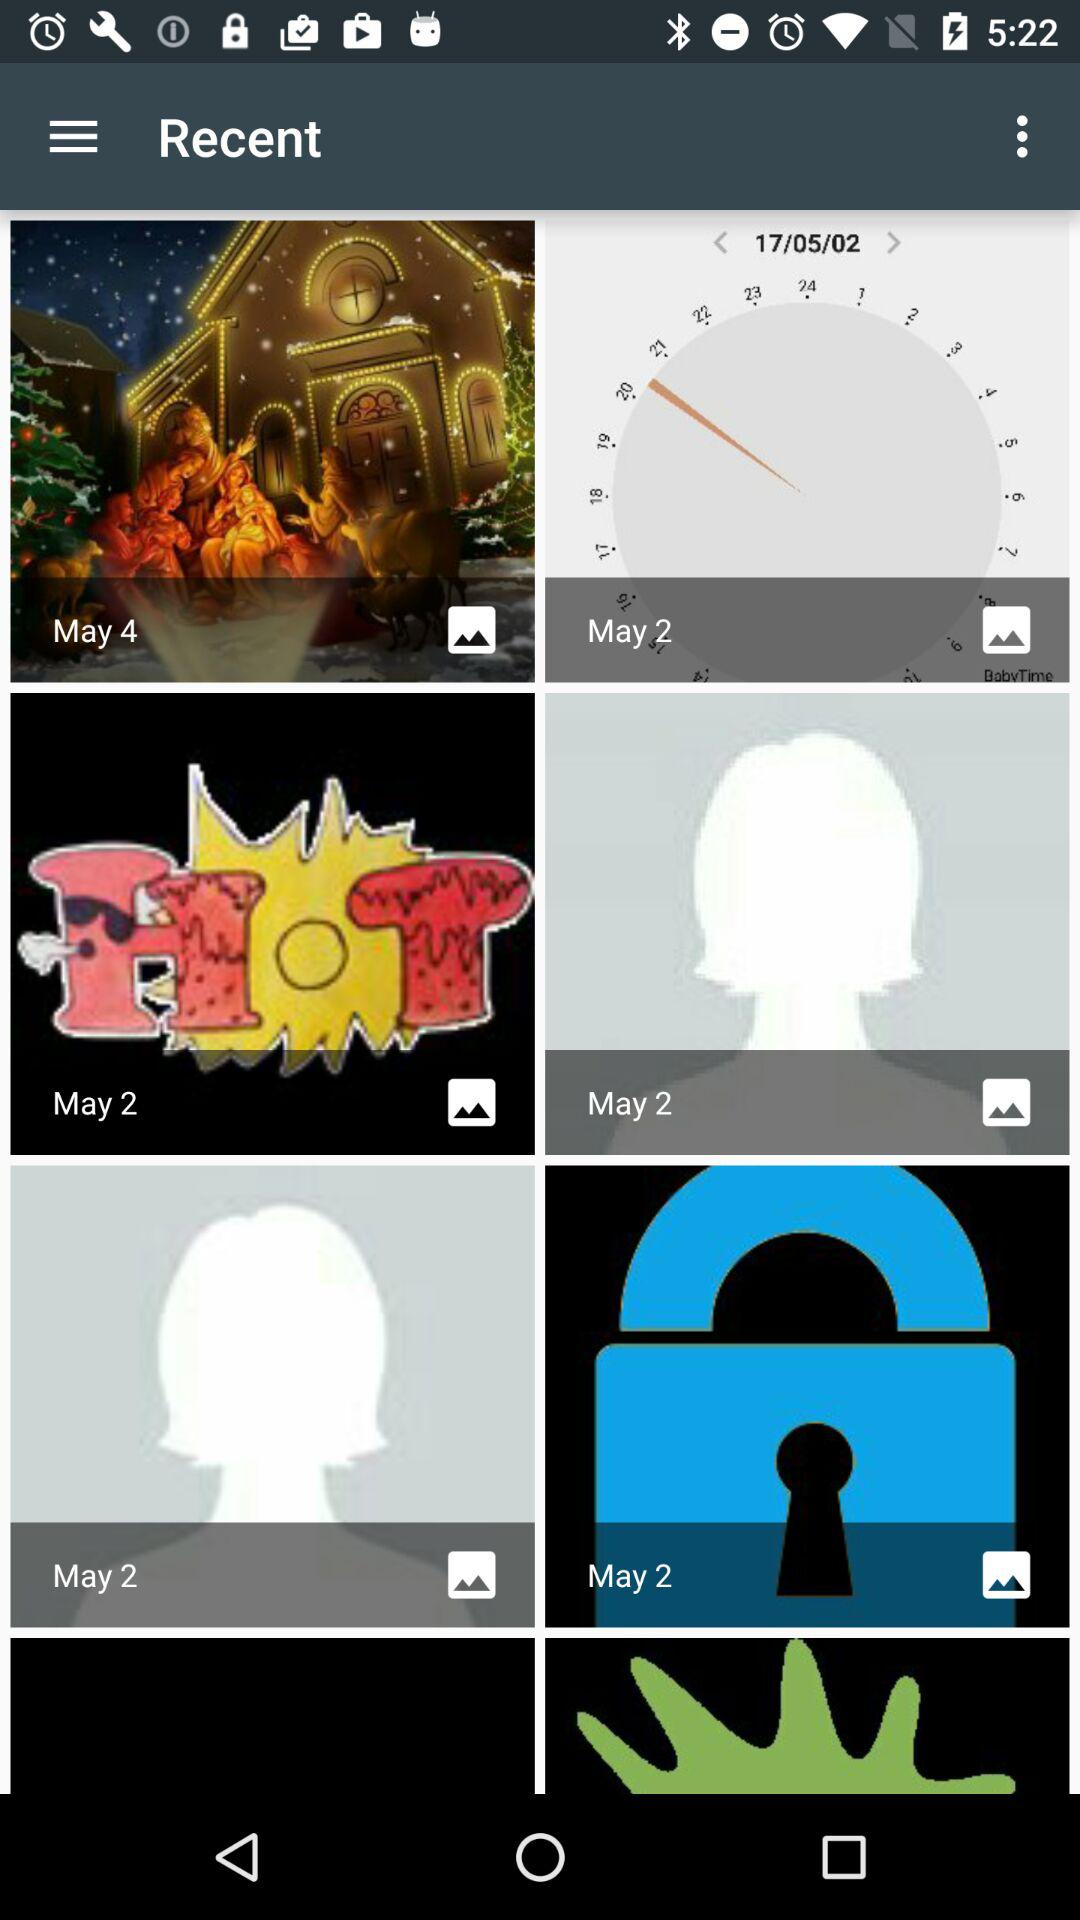On which dates recent searches has done?
When the provided information is insufficient, respond with <no answer>. <no answer> 